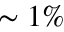<formula> <loc_0><loc_0><loc_500><loc_500>\sim 1 \%</formula> 